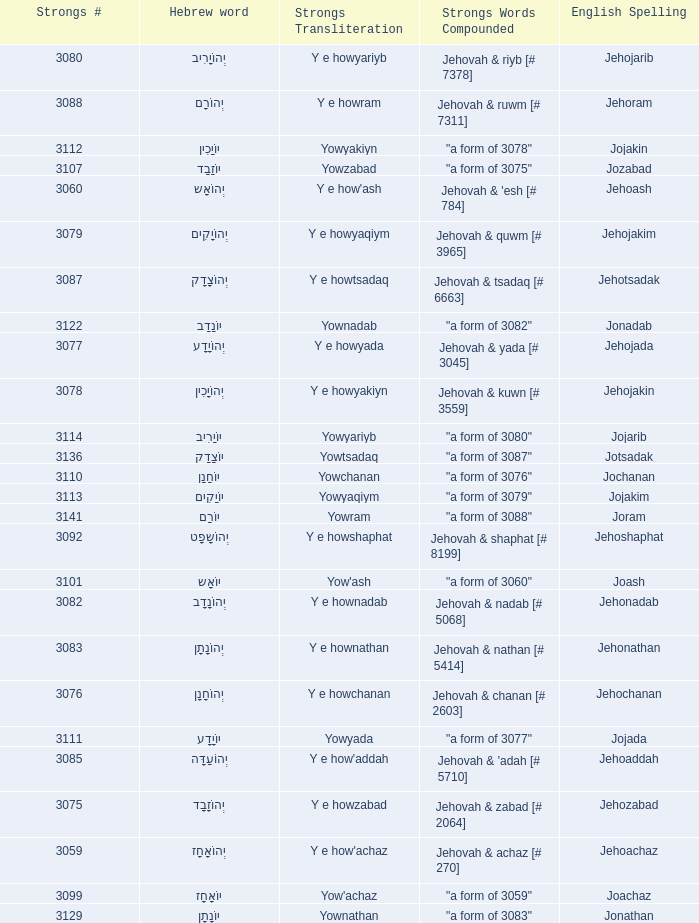What is the english spelling of the word that has the strongs trasliteration of y e howram? Jehoram. 